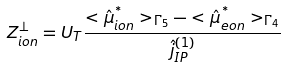Convert formula to latex. <formula><loc_0><loc_0><loc_500><loc_500>Z _ { i o n } ^ { \perp } = U _ { T } \frac { < \hat { \mu } _ { i o n } ^ { ^ { * } } > _ { \Gamma _ { 5 } } - < \hat { \mu } _ { e o n } ^ { ^ { * } } > _ { \Gamma _ { 4 } } } { \hat { j } _ { I P } ^ { ( 1 ) } }</formula> 